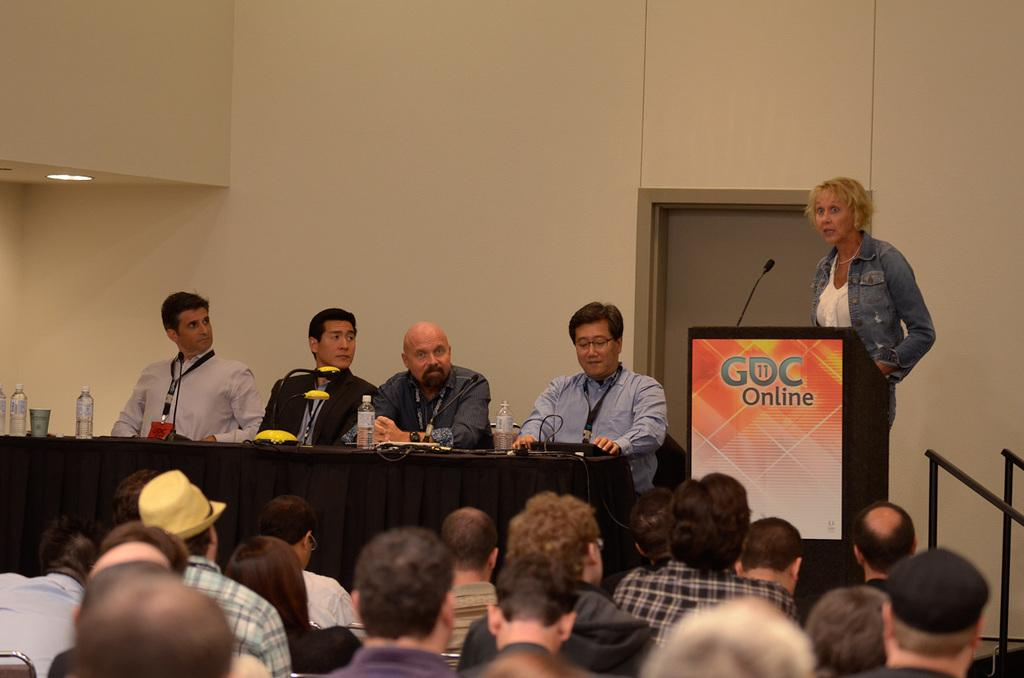What is present in the image that serves as a background or boundary? There is a wall in the image. What are the people in the image doing? The people are sitting on chairs in the image. What is the main piece of furniture in the image? There is a table in the image. What items can be seen on the table? There are bottles, microphones (mics), and papers on the table. Is there a volcano erupting in the image? No, there is no volcano present in the image. How does the land in the image contribute to the emotions of the people sitting on chairs? The image does not mention any land or emotions of the people, so it is not possible to answer this question. 